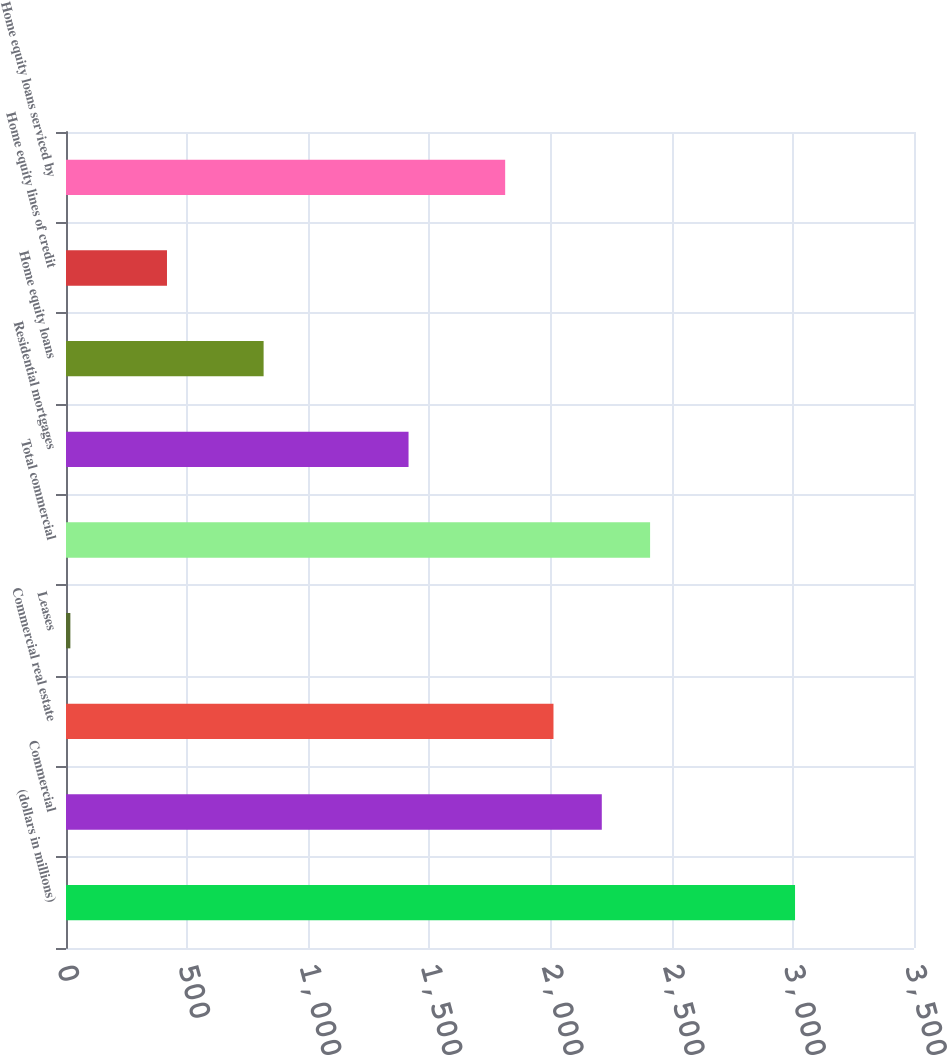<chart> <loc_0><loc_0><loc_500><loc_500><bar_chart><fcel>(dollars in millions)<fcel>Commercial<fcel>Commercial real estate<fcel>Leases<fcel>Total commercial<fcel>Residential mortgages<fcel>Home equity loans<fcel>Home equity lines of credit<fcel>Home equity loans serviced by<nl><fcel>3009<fcel>2211.4<fcel>2012<fcel>18<fcel>2410.8<fcel>1413.8<fcel>815.6<fcel>416.8<fcel>1812.6<nl></chart> 